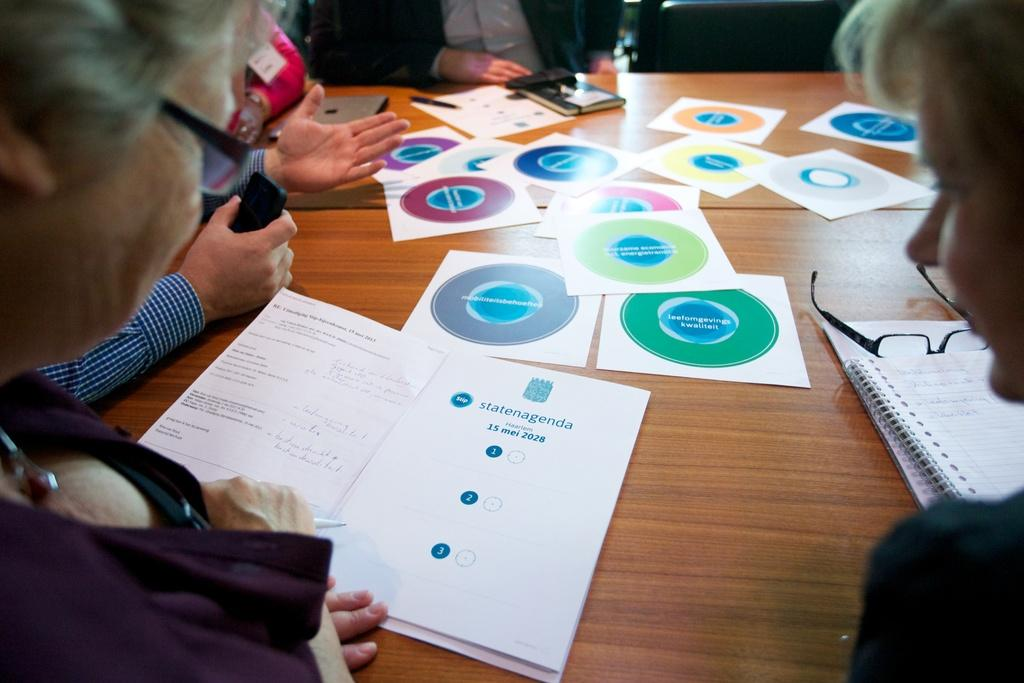What is the main object in the image? There is a table in the image. What are the people in the image doing? People are sitting around the table. What items can be seen on the table? There are books, papers, glasses, and tabs on the table. What type of dog is sitting under the table in the image? There is no dog present in the image; only people and objects are visible. 